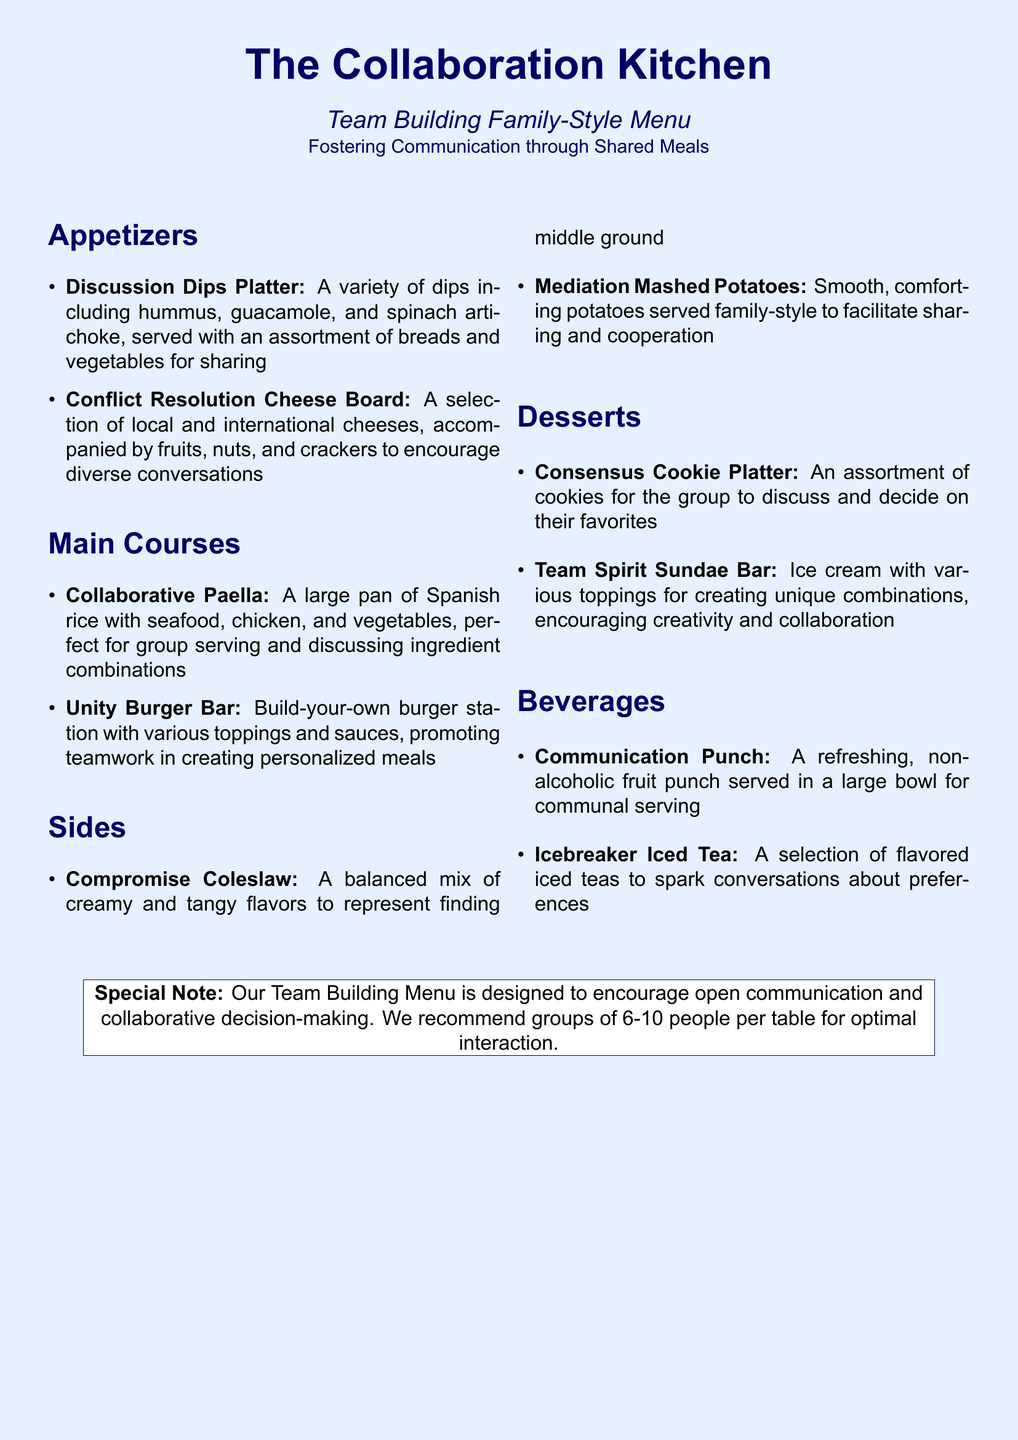What is the name of the menu? The name of the menu is prominently displayed at the top of the document.
Answer: The Collaboration Kitchen What section contains dessert options? The section headings identify the various courses offered, including desserts.
Answer: Desserts How many people is the Team Building Menu designed for? The special note at the bottom indicates an optimal group size for interaction.
Answer: 6-10 people What is served in a large bowl for communal serving? The beverages section specifies a refreshing beverage serves in a large bowl.
Answer: Communication Punch Which main course allows for personalized meal creation? The main courses detail a station that emphasizes teamwork in meal preparation.
Answer: Unity Burger Bar What is the theme of the menu? The document emphasizes communication and collaboration through shared meals.
Answer: Fostering Communication What type of platter encourages discussion about favorites? The dessert section outlines an assortment that prompts group conversation.
Answer: Consensus Cookie Platter What is the first item listed under appetizers? The appetizers section provides a list, starting with a specific item for sharing.
Answer: Discussion Dips Platter 